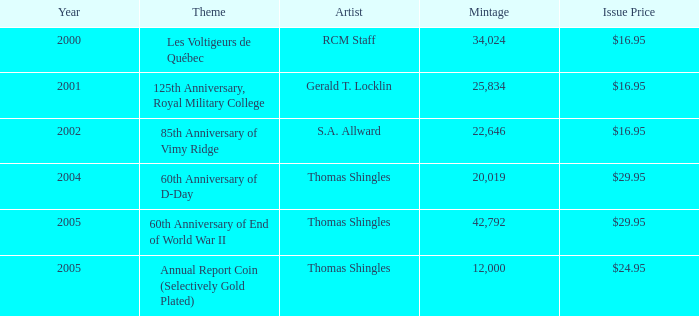What year was S.A. Allward's theme that had an issue price of $16.95 released? 2002.0. Parse the table in full. {'header': ['Year', 'Theme', 'Artist', 'Mintage', 'Issue Price'], 'rows': [['2000', 'Les Voltigeurs de Québec', 'RCM Staff', '34,024', '$16.95'], ['2001', '125th Anniversary, Royal Military College', 'Gerald T. Locklin', '25,834', '$16.95'], ['2002', '85th Anniversary of Vimy Ridge', 'S.A. Allward', '22,646', '$16.95'], ['2004', '60th Anniversary of D-Day', 'Thomas Shingles', '20,019', '$29.95'], ['2005', '60th Anniversary of End of World War II', 'Thomas Shingles', '42,792', '$29.95'], ['2005', 'Annual Report Coin (Selectively Gold Plated)', 'Thomas Shingles', '12,000', '$24.95']]} 